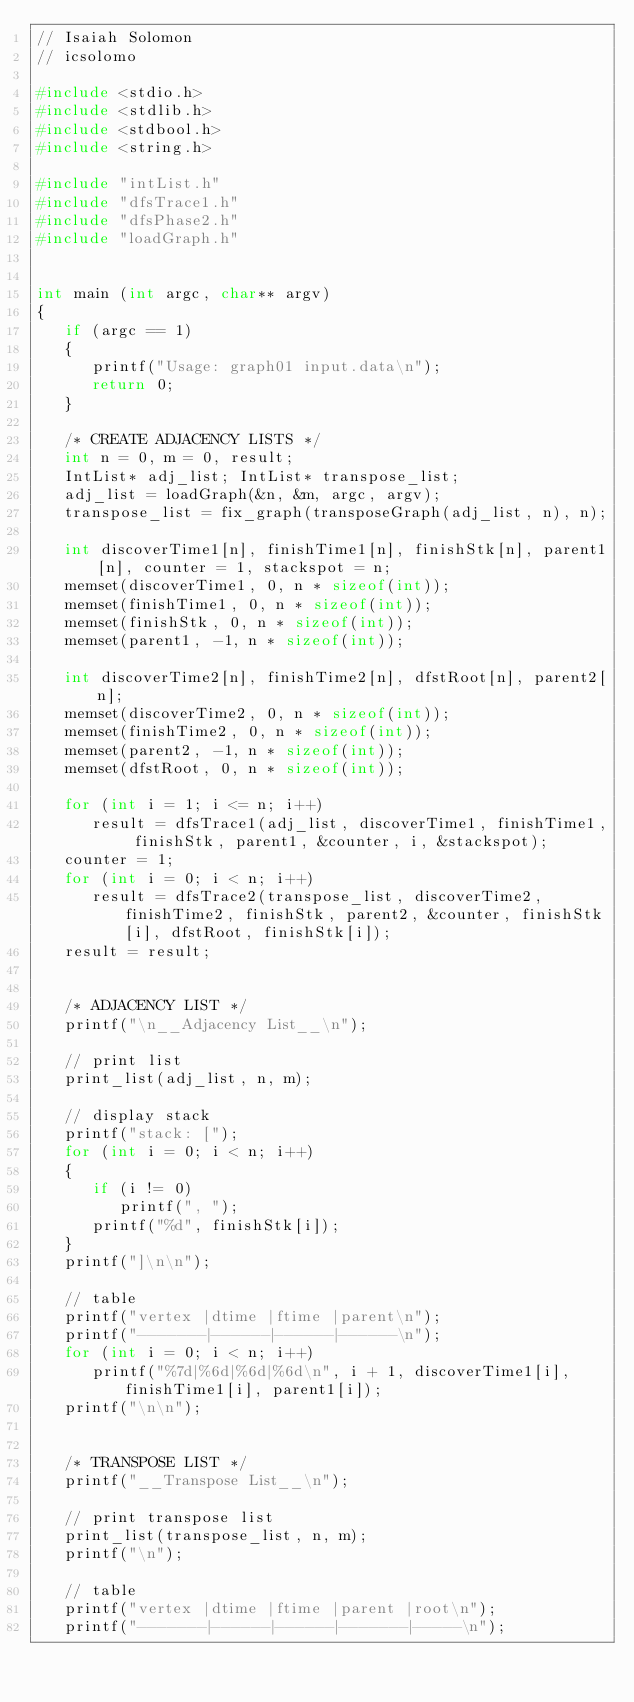Convert code to text. <code><loc_0><loc_0><loc_500><loc_500><_C_>// Isaiah Solomon
// icsolomo

#include <stdio.h>
#include <stdlib.h>
#include <stdbool.h>
#include <string.h>

#include "intList.h"
#include "dfsTrace1.h"
#include "dfsPhase2.h"
#include "loadGraph.h"


int main (int argc, char** argv)
{
   if (argc == 1)
   {
      printf("Usage: graph01 input.data\n");
      return 0;
   }

   /* CREATE ADJACENCY LISTS */
   int n = 0, m = 0, result;
   IntList* adj_list; IntList* transpose_list;
   adj_list = loadGraph(&n, &m, argc, argv);
   transpose_list = fix_graph(transposeGraph(adj_list, n), n);

   int discoverTime1[n], finishTime1[n], finishStk[n], parent1[n], counter = 1, stackspot = n;
   memset(discoverTime1, 0, n * sizeof(int));
   memset(finishTime1, 0, n * sizeof(int));
   memset(finishStk, 0, n * sizeof(int));
   memset(parent1, -1, n * sizeof(int));

   int discoverTime2[n], finishTime2[n], dfstRoot[n], parent2[n];
   memset(discoverTime2, 0, n * sizeof(int));
   memset(finishTime2, 0, n * sizeof(int));
   memset(parent2, -1, n * sizeof(int));
   memset(dfstRoot, 0, n * sizeof(int));

   for (int i = 1; i <= n; i++)
      result = dfsTrace1(adj_list, discoverTime1, finishTime1, finishStk, parent1, &counter, i, &stackspot);
   counter = 1;
   for (int i = 0; i < n; i++)
      result = dfsTrace2(transpose_list, discoverTime2, finishTime2, finishStk, parent2, &counter, finishStk[i], dfstRoot, finishStk[i]);
   result = result;


   /* ADJACENCY LIST */
   printf("\n__Adjacency List__\n");

   // print list
   print_list(adj_list, n, m);

   // display stack
   printf("stack: [");
   for (int i = 0; i < n; i++)
   {
      if (i != 0)
         printf(", ");
      printf("%d", finishStk[i]);
   }
   printf("]\n\n");

   // table
   printf("vertex |dtime |ftime |parent\n");
   printf("-------|------|------|------\n");
   for (int i = 0; i < n; i++)
      printf("%7d|%6d|%6d|%6d\n", i + 1, discoverTime1[i], finishTime1[i], parent1[i]);
   printf("\n\n");


   /* TRANSPOSE LIST */
   printf("__Transpose List__\n");

   // print transpose list
   print_list(transpose_list, n, m);
   printf("\n");

   // table
   printf("vertex |dtime |ftime |parent |root\n");
   printf("-------|------|------|-------|-----\n");</code> 